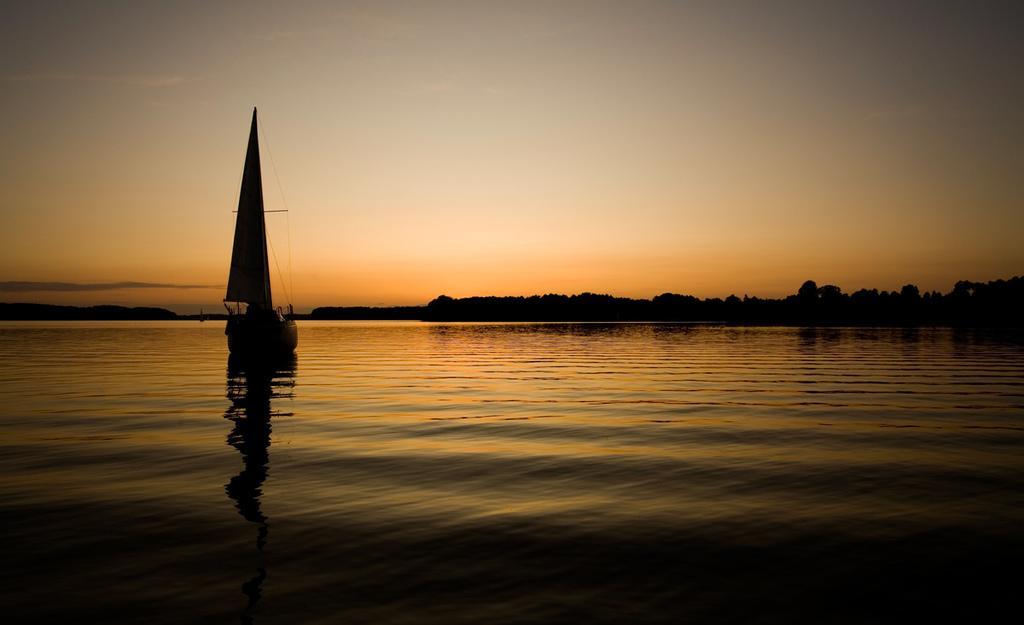Could you give a brief overview of what you see in this image? In this image, I can see a boat on the water. In the background, there are trees, hill and the sky. 